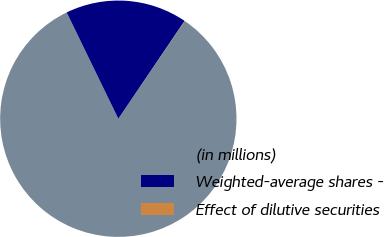Convert chart to OTSL. <chart><loc_0><loc_0><loc_500><loc_500><pie_chart><fcel>(in millions)<fcel>Weighted-average shares -<fcel>Effect of dilutive securities<nl><fcel>83.29%<fcel>16.68%<fcel>0.03%<nl></chart> 